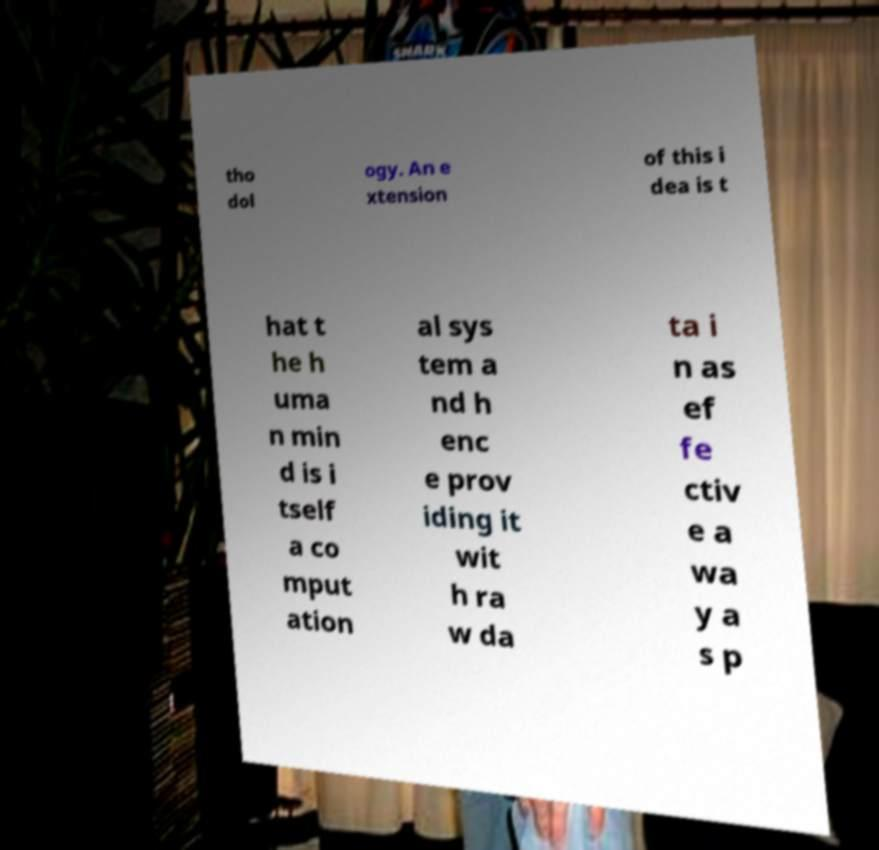For documentation purposes, I need the text within this image transcribed. Could you provide that? tho dol ogy. An e xtension of this i dea is t hat t he h uma n min d is i tself a co mput ation al sys tem a nd h enc e prov iding it wit h ra w da ta i n as ef fe ctiv e a wa y a s p 